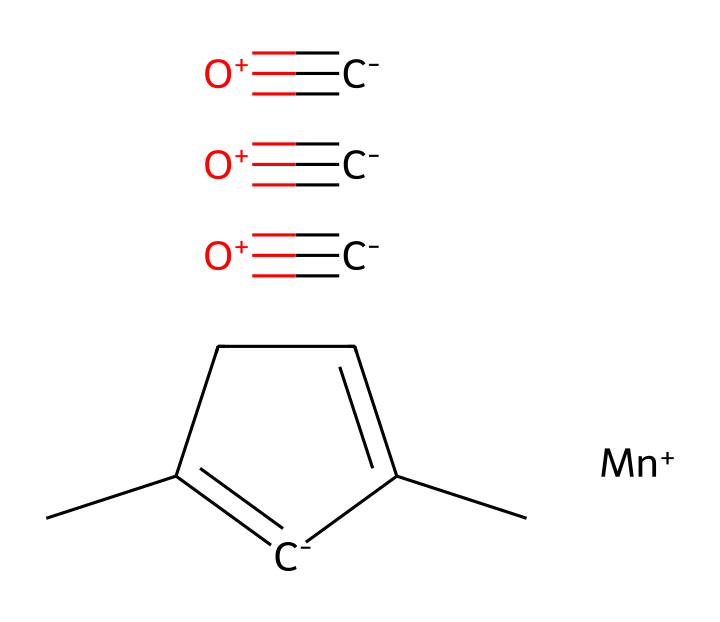What is the molecular formula of MMT? To determine the molecular formula, count the number of each type of atom present in the SMILES: It contains 9 carbon atoms (C), 10 hydrogen atoms (H), 1 manganese atom (Mn), and 3 oxygen atoms (O). Hence, the molecular formula is C9H10MnO3.
Answer: C9H10MnO3 How many carbon atoms are present? By analyzing the SMILES representation, I find 9 carbon atoms indicated by the letter 'C' in the structure.
Answer: 9 What type of compound is MMT classified as? MMT is classified as an organomanganese compound due to the presence of a manganese atom bonded to an organic structure.
Answer: organomanganese What element is represented by 'Mn' in the structure? The 'Mn' in the chemical structure stands for manganese, which is a transition metal commonly used in additives to enhance fuel properties.
Answer: manganese How does MMT improve fuel performance? MMT enhances fuel performance by increasing the octane rating of gasoline, helping to prevent knocking during combustion.
Answer: increases octane rating What is the significance of the three 'C#O+' in the structure? The three 'C#O+' groups represent carbonyl functional groups (C=O), indicating that the compound has strong oxidizing properties which contribute to its effectiveness as an octane booster.
Answer: strong oxidizing properties 